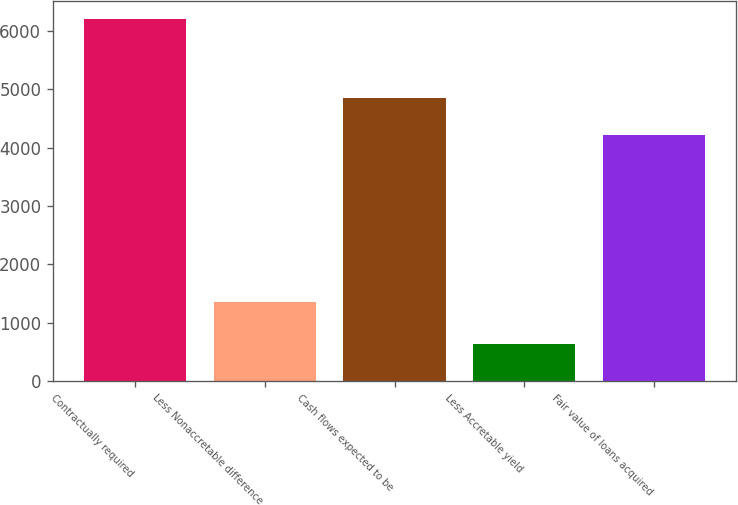Convert chart to OTSL. <chart><loc_0><loc_0><loc_500><loc_500><bar_chart><fcel>Contractually required<fcel>Less Nonaccretable difference<fcel>Cash flows expected to be<fcel>Less Accretable yield<fcel>Fair value of loans acquired<nl><fcel>6205<fcel>1357<fcel>4848<fcel>627<fcel>4221<nl></chart> 